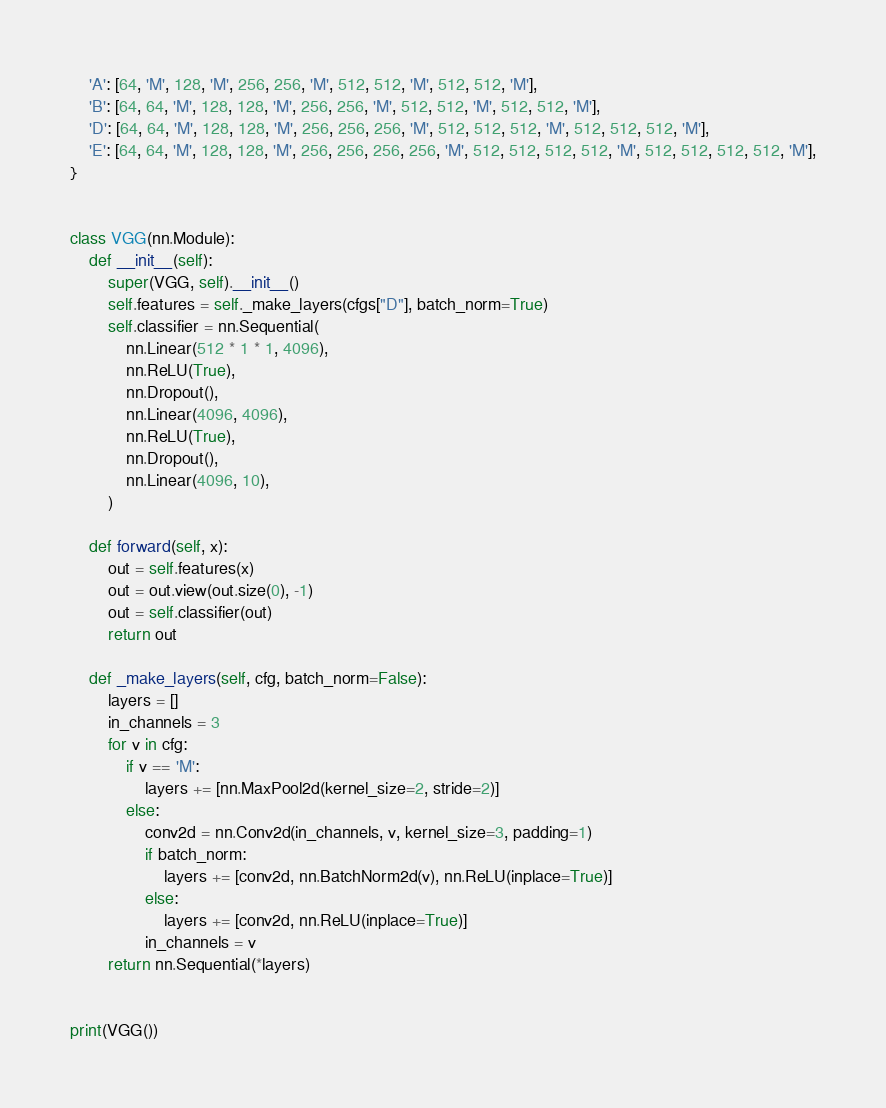Convert code to text. <code><loc_0><loc_0><loc_500><loc_500><_Python_>    'A': [64, 'M', 128, 'M', 256, 256, 'M', 512, 512, 'M', 512, 512, 'M'],
    'B': [64, 64, 'M', 128, 128, 'M', 256, 256, 'M', 512, 512, 'M', 512, 512, 'M'],
    'D': [64, 64, 'M', 128, 128, 'M', 256, 256, 256, 'M', 512, 512, 512, 'M', 512, 512, 512, 'M'],
    'E': [64, 64, 'M', 128, 128, 'M', 256, 256, 256, 256, 'M', 512, 512, 512, 512, 'M', 512, 512, 512, 512, 'M'],
}


class VGG(nn.Module):
    def __init__(self):
        super(VGG, self).__init__()
        self.features = self._make_layers(cfgs["D"], batch_norm=True)
        self.classifier = nn.Sequential(
            nn.Linear(512 * 1 * 1, 4096),
            nn.ReLU(True),
            nn.Dropout(),
            nn.Linear(4096, 4096),
            nn.ReLU(True),
            nn.Dropout(),
            nn.Linear(4096, 10),
        )

    def forward(self, x):
        out = self.features(x)
        out = out.view(out.size(0), -1)
        out = self.classifier(out)
        return out

    def _make_layers(self, cfg, batch_norm=False):
        layers = []
        in_channels = 3
        for v in cfg:
            if v == 'M':
                layers += [nn.MaxPool2d(kernel_size=2, stride=2)]
            else:
                conv2d = nn.Conv2d(in_channels, v, kernel_size=3, padding=1)
                if batch_norm:
                    layers += [conv2d, nn.BatchNorm2d(v), nn.ReLU(inplace=True)]
                else:
                    layers += [conv2d, nn.ReLU(inplace=True)]
                in_channels = v
        return nn.Sequential(*layers)


print(VGG())
</code> 